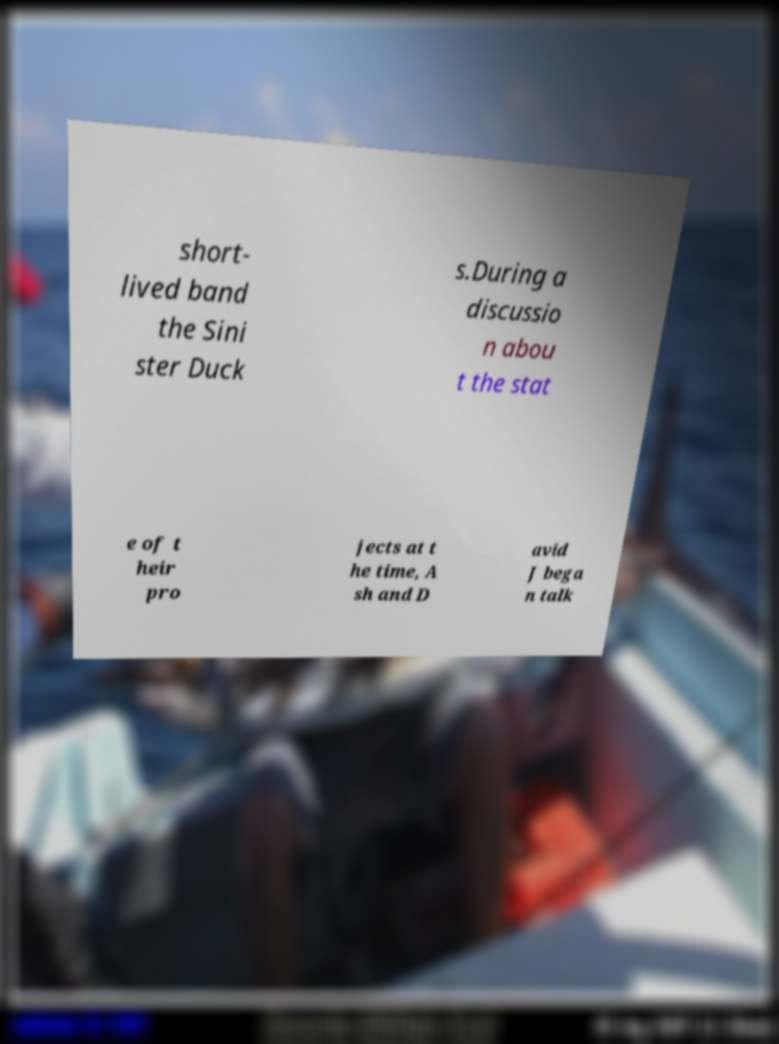For documentation purposes, I need the text within this image transcribed. Could you provide that? short- lived band the Sini ster Duck s.During a discussio n abou t the stat e of t heir pro jects at t he time, A sh and D avid J bega n talk 